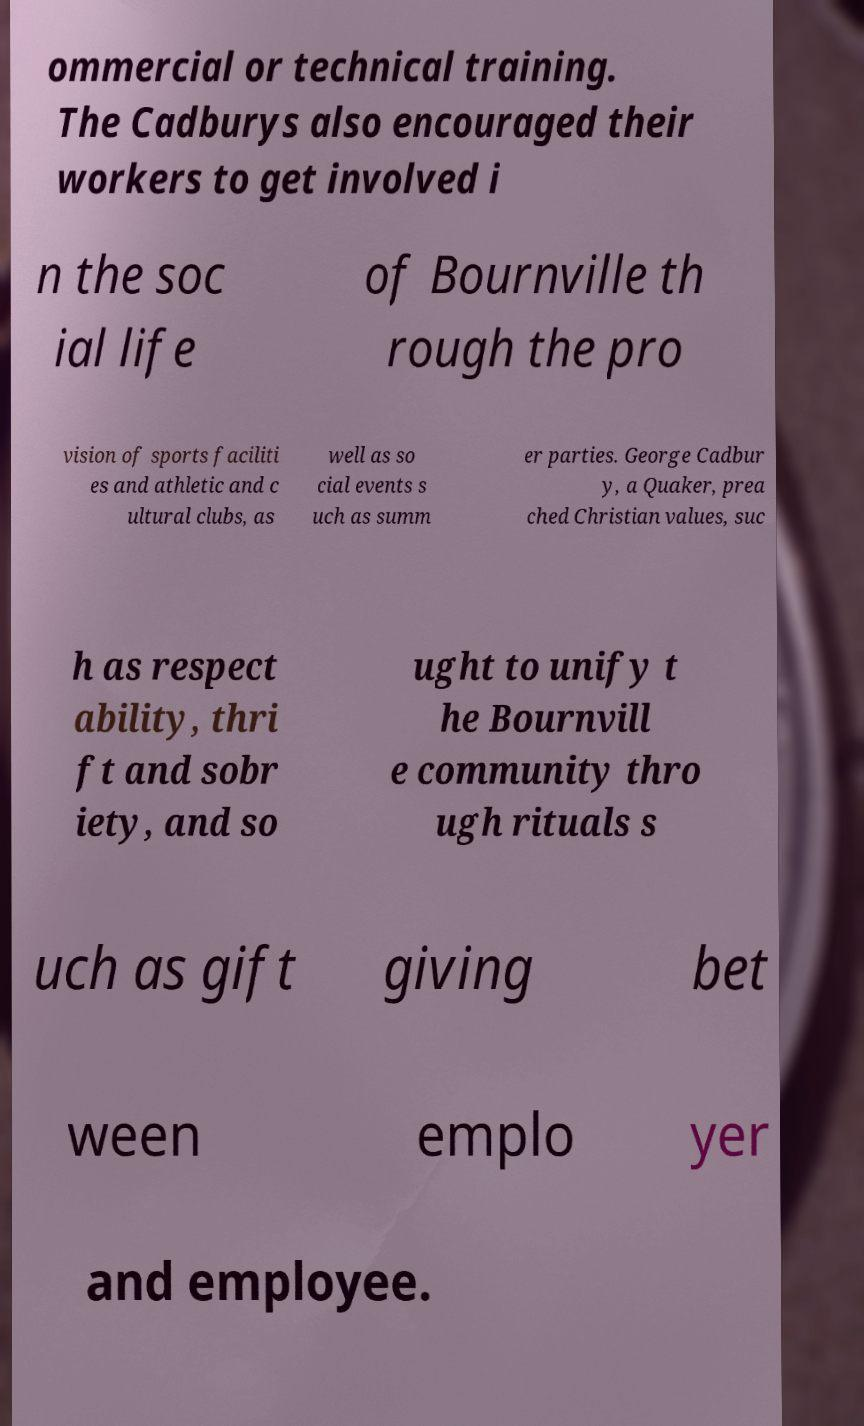What messages or text are displayed in this image? I need them in a readable, typed format. ommercial or technical training. The Cadburys also encouraged their workers to get involved i n the soc ial life of Bournville th rough the pro vision of sports faciliti es and athletic and c ultural clubs, as well as so cial events s uch as summ er parties. George Cadbur y, a Quaker, prea ched Christian values, suc h as respect ability, thri ft and sobr iety, and so ught to unify t he Bournvill e community thro ugh rituals s uch as gift giving bet ween emplo yer and employee. 